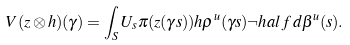<formula> <loc_0><loc_0><loc_500><loc_500>V ( z \otimes h ) ( \gamma ) = \int _ { S } U _ { s } \pi ( z ( \gamma s ) ) h \rho ^ { u } ( \gamma s ) \neg h a l f \, d \beta ^ { u } ( s ) .</formula> 